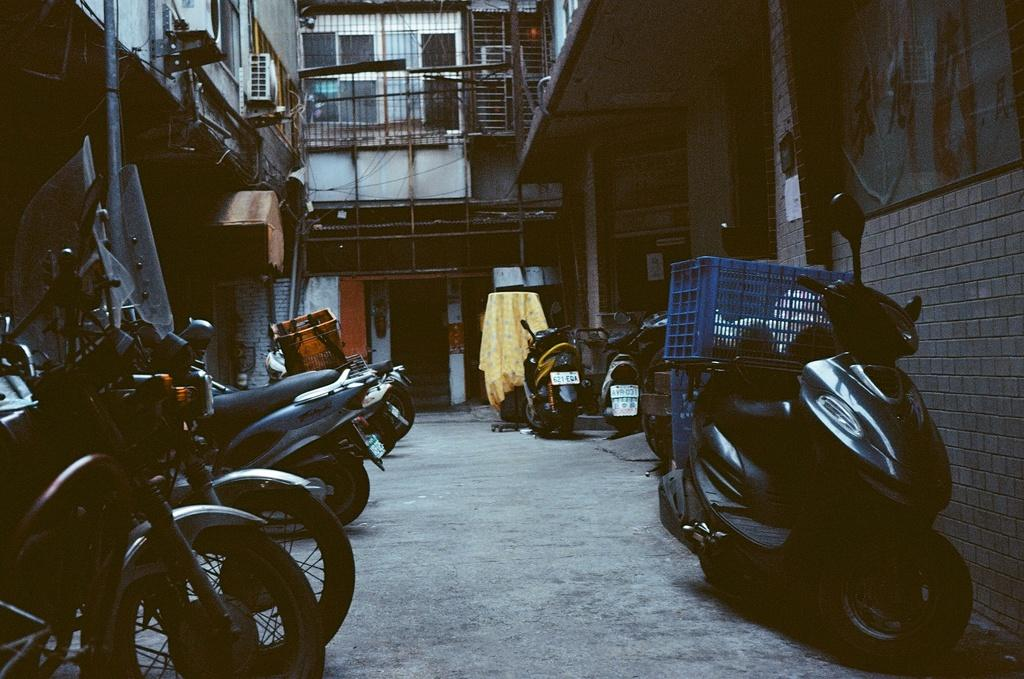What is the main subject of the image? The main subject of the image is many motorbikes on the road. What can be seen on the right side of the image? There are blue color boxes on the right side of the image. What is visible in the background of the image? There is a building in the background of the image. What architectural feature is associated with the building in the background? There is a railing associated with the building in the background. What type of nose can be seen on the motorbikes in the image? Motorbikes do not have noses, so there is no nose present on the motorbikes in the image. What type of tub is visible in the image? There is no tub present in the image; it features motorbikes on the road, blue color boxes, a building, and a railing. 